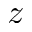Convert formula to latex. <formula><loc_0><loc_0><loc_500><loc_500>z</formula> 